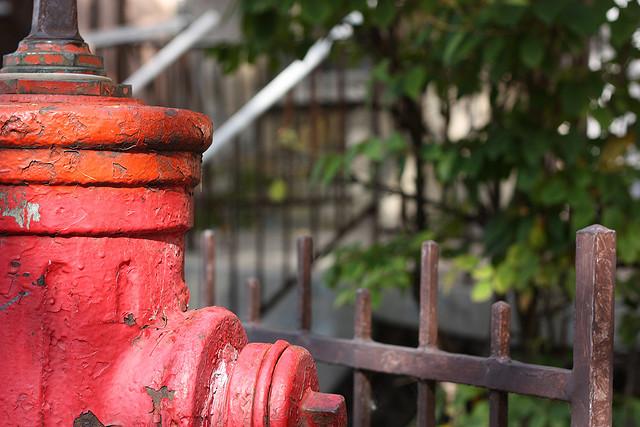What color is the fire hydrant?
Answer briefly. Red. Is the fire hydrant freshly painted?
Quick response, please. No. What is the pattern of the bars?
Answer briefly. Up and down. 